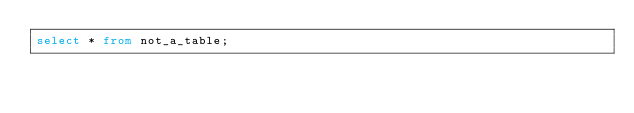<code> <loc_0><loc_0><loc_500><loc_500><_SQL_>select * from not_a_table;</code> 